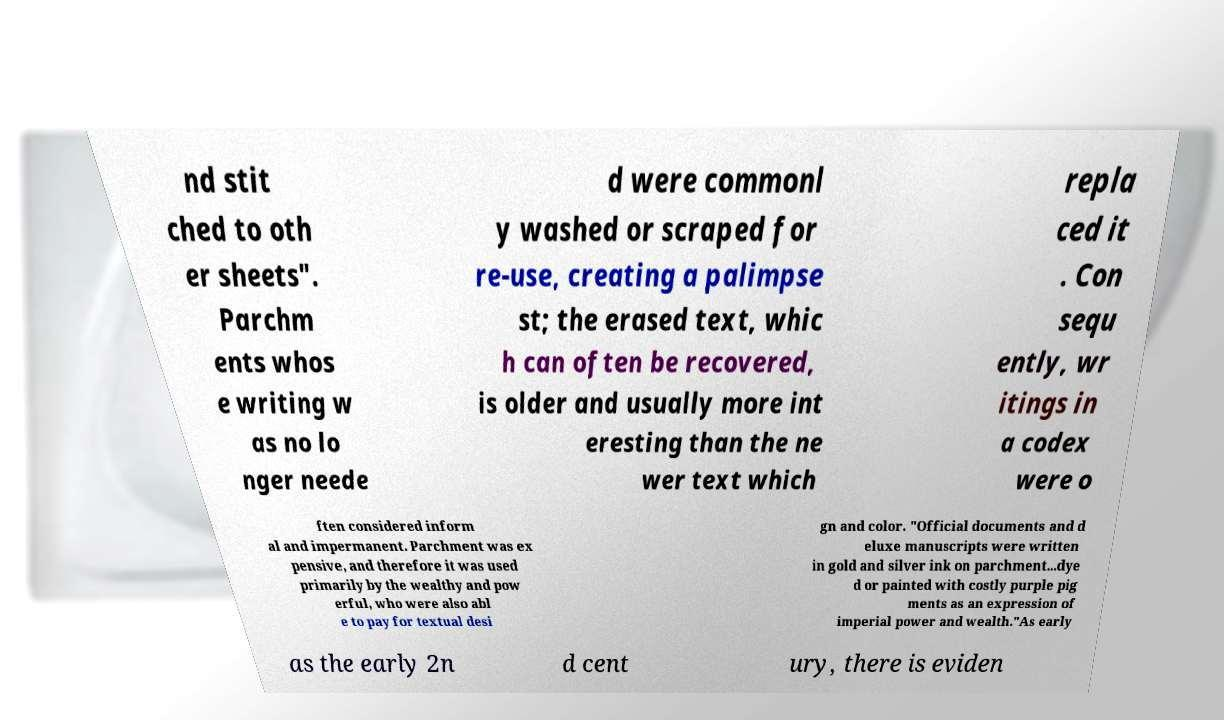Can you read and provide the text displayed in the image?This photo seems to have some interesting text. Can you extract and type it out for me? nd stit ched to oth er sheets". Parchm ents whos e writing w as no lo nger neede d were commonl y washed or scraped for re-use, creating a palimpse st; the erased text, whic h can often be recovered, is older and usually more int eresting than the ne wer text which repla ced it . Con sequ ently, wr itings in a codex were o ften considered inform al and impermanent. Parchment was ex pensive, and therefore it was used primarily by the wealthy and pow erful, who were also abl e to pay for textual desi gn and color. "Official documents and d eluxe manuscripts were written in gold and silver ink on parchment...dye d or painted with costly purple pig ments as an expression of imperial power and wealth."As early as the early 2n d cent ury, there is eviden 